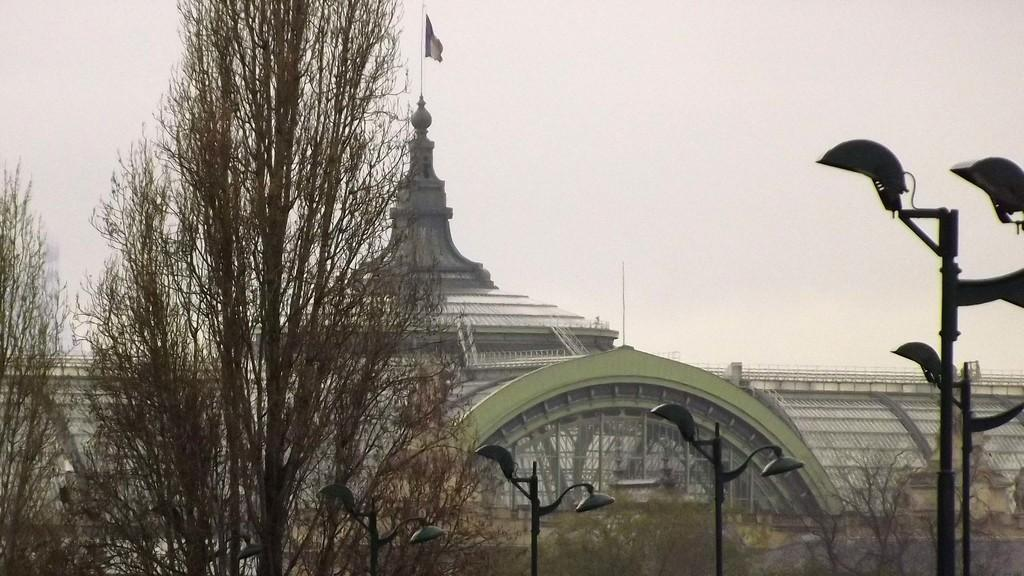What type of natural elements can be seen in the image? There are trees in the image. What man-made structures are present in the image? There are light poles in the image. What can be seen in the background of the image? There is an architecture and the sky visible in the background of the image. Can you see a swing in the image? There is no swing present in the image. What type of cable can be seen connecting the trees in the image? There are no cables connecting the trees in the image. 